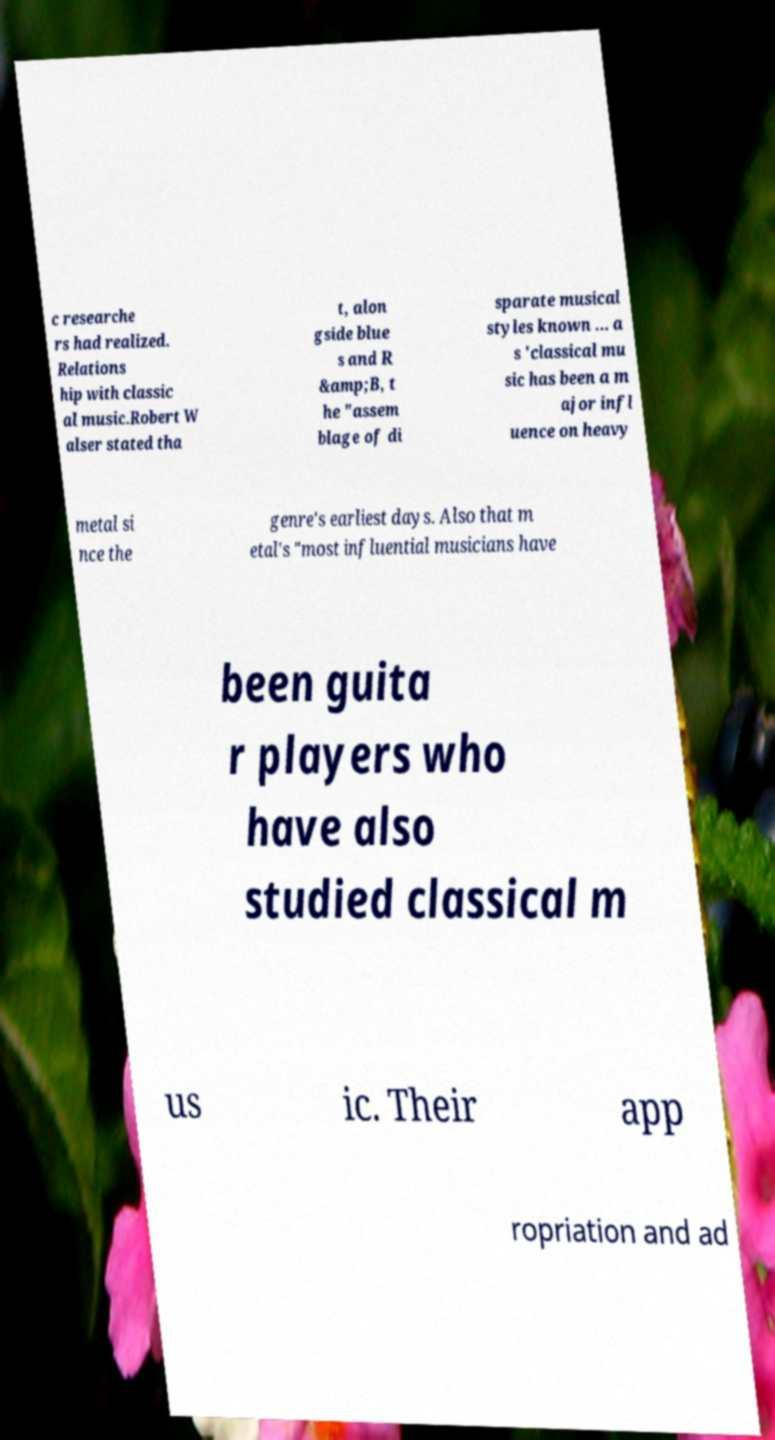Can you accurately transcribe the text from the provided image for me? c researche rs had realized. Relations hip with classic al music.Robert W alser stated tha t, alon gside blue s and R &amp;B, t he "assem blage of di sparate musical styles known ... a s 'classical mu sic has been a m ajor infl uence on heavy metal si nce the genre's earliest days. Also that m etal's "most influential musicians have been guita r players who have also studied classical m us ic. Their app ropriation and ad 